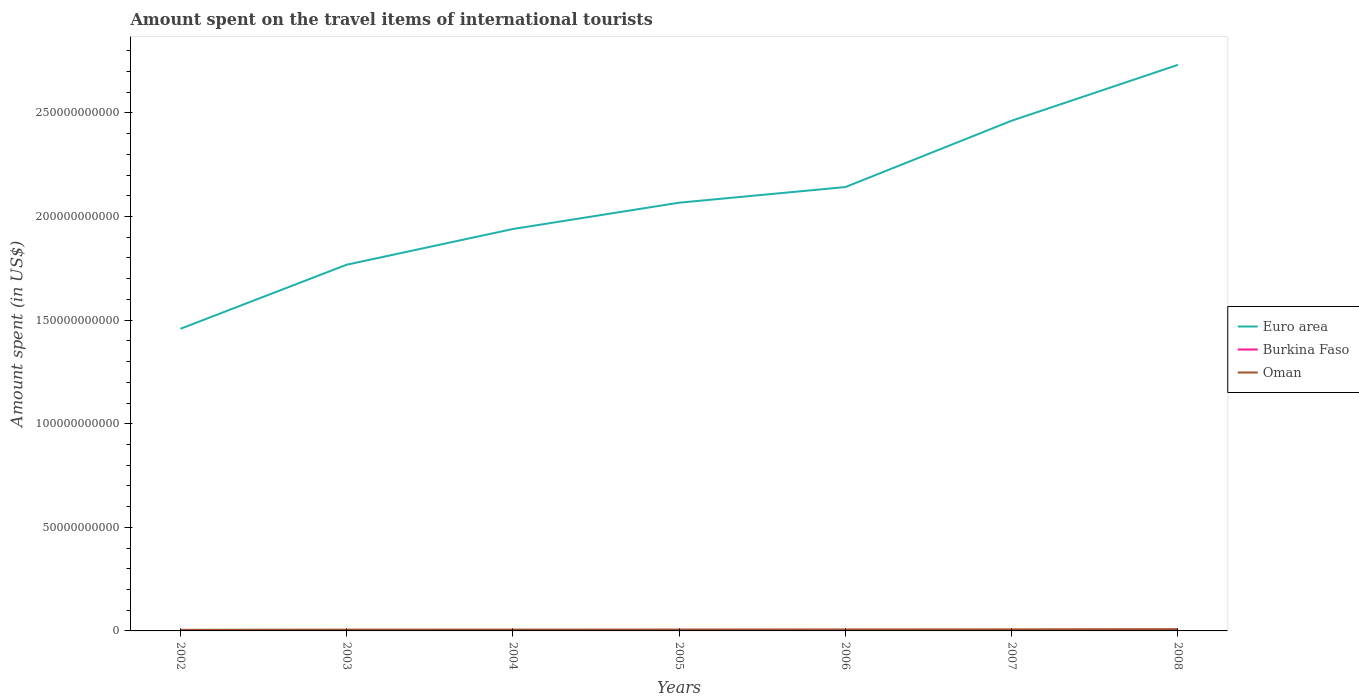How many different coloured lines are there?
Give a very brief answer. 3. Does the line corresponding to Burkina Faso intersect with the line corresponding to Oman?
Provide a succinct answer. No. Is the number of lines equal to the number of legend labels?
Give a very brief answer. Yes. Across all years, what is the maximum amount spent on the travel items of international tourists in Burkina Faso?
Give a very brief answer. 2.20e+07. In which year was the amount spent on the travel items of international tourists in Oman maximum?
Provide a succinct answer. 2002. What is the total amount spent on the travel items of international tourists in Euro area in the graph?
Your response must be concise. -1.00e+11. What is the difference between the highest and the second highest amount spent on the travel items of international tourists in Euro area?
Give a very brief answer. 1.27e+11. What is the difference between two consecutive major ticks on the Y-axis?
Your response must be concise. 5.00e+1. Are the values on the major ticks of Y-axis written in scientific E-notation?
Ensure brevity in your answer.  No. Does the graph contain any zero values?
Your answer should be compact. No. How many legend labels are there?
Ensure brevity in your answer.  3. What is the title of the graph?
Keep it short and to the point. Amount spent on the travel items of international tourists. Does "Aruba" appear as one of the legend labels in the graph?
Offer a very short reply. No. What is the label or title of the Y-axis?
Offer a terse response. Amount spent (in US$). What is the Amount spent (in US$) of Euro area in 2002?
Provide a short and direct response. 1.46e+11. What is the Amount spent (in US$) in Burkina Faso in 2002?
Your response must be concise. 2.20e+07. What is the Amount spent (in US$) of Oman in 2002?
Provide a succinct answer. 5.30e+08. What is the Amount spent (in US$) in Euro area in 2003?
Offer a very short reply. 1.77e+11. What is the Amount spent (in US$) of Burkina Faso in 2003?
Make the answer very short. 3.10e+07. What is the Amount spent (in US$) in Oman in 2003?
Provide a succinct answer. 6.30e+08. What is the Amount spent (in US$) of Euro area in 2004?
Provide a succinct answer. 1.94e+11. What is the Amount spent (in US$) of Burkina Faso in 2004?
Your response must be concise. 3.90e+07. What is the Amount spent (in US$) in Oman in 2004?
Offer a terse response. 6.44e+08. What is the Amount spent (in US$) of Euro area in 2005?
Keep it short and to the point. 2.07e+11. What is the Amount spent (in US$) in Burkina Faso in 2005?
Provide a short and direct response. 4.60e+07. What is the Amount spent (in US$) of Oman in 2005?
Your response must be concise. 6.68e+08. What is the Amount spent (in US$) of Euro area in 2006?
Provide a succinct answer. 2.14e+11. What is the Amount spent (in US$) in Burkina Faso in 2006?
Your answer should be very brief. 5.50e+07. What is the Amount spent (in US$) in Oman in 2006?
Give a very brief answer. 7.12e+08. What is the Amount spent (in US$) of Euro area in 2007?
Provide a succinct answer. 2.46e+11. What is the Amount spent (in US$) in Burkina Faso in 2007?
Your answer should be very brief. 5.80e+07. What is the Amount spent (in US$) in Oman in 2007?
Your answer should be compact. 7.52e+08. What is the Amount spent (in US$) in Euro area in 2008?
Ensure brevity in your answer.  2.73e+11. What is the Amount spent (in US$) of Burkina Faso in 2008?
Provide a succinct answer. 6.30e+07. What is the Amount spent (in US$) in Oman in 2008?
Your answer should be compact. 8.56e+08. Across all years, what is the maximum Amount spent (in US$) in Euro area?
Offer a very short reply. 2.73e+11. Across all years, what is the maximum Amount spent (in US$) of Burkina Faso?
Provide a short and direct response. 6.30e+07. Across all years, what is the maximum Amount spent (in US$) in Oman?
Offer a terse response. 8.56e+08. Across all years, what is the minimum Amount spent (in US$) in Euro area?
Make the answer very short. 1.46e+11. Across all years, what is the minimum Amount spent (in US$) in Burkina Faso?
Give a very brief answer. 2.20e+07. Across all years, what is the minimum Amount spent (in US$) of Oman?
Ensure brevity in your answer.  5.30e+08. What is the total Amount spent (in US$) of Euro area in the graph?
Provide a short and direct response. 1.46e+12. What is the total Amount spent (in US$) in Burkina Faso in the graph?
Your answer should be compact. 3.14e+08. What is the total Amount spent (in US$) in Oman in the graph?
Your answer should be very brief. 4.79e+09. What is the difference between the Amount spent (in US$) of Euro area in 2002 and that in 2003?
Provide a short and direct response. -3.09e+1. What is the difference between the Amount spent (in US$) of Burkina Faso in 2002 and that in 2003?
Offer a terse response. -9.00e+06. What is the difference between the Amount spent (in US$) in Oman in 2002 and that in 2003?
Make the answer very short. -1.00e+08. What is the difference between the Amount spent (in US$) in Euro area in 2002 and that in 2004?
Keep it short and to the point. -4.82e+1. What is the difference between the Amount spent (in US$) of Burkina Faso in 2002 and that in 2004?
Make the answer very short. -1.70e+07. What is the difference between the Amount spent (in US$) in Oman in 2002 and that in 2004?
Offer a very short reply. -1.14e+08. What is the difference between the Amount spent (in US$) of Euro area in 2002 and that in 2005?
Give a very brief answer. -6.09e+1. What is the difference between the Amount spent (in US$) in Burkina Faso in 2002 and that in 2005?
Your answer should be compact. -2.40e+07. What is the difference between the Amount spent (in US$) of Oman in 2002 and that in 2005?
Provide a short and direct response. -1.38e+08. What is the difference between the Amount spent (in US$) in Euro area in 2002 and that in 2006?
Make the answer very short. -6.84e+1. What is the difference between the Amount spent (in US$) in Burkina Faso in 2002 and that in 2006?
Your answer should be very brief. -3.30e+07. What is the difference between the Amount spent (in US$) in Oman in 2002 and that in 2006?
Your answer should be very brief. -1.82e+08. What is the difference between the Amount spent (in US$) of Euro area in 2002 and that in 2007?
Your response must be concise. -1.00e+11. What is the difference between the Amount spent (in US$) in Burkina Faso in 2002 and that in 2007?
Ensure brevity in your answer.  -3.60e+07. What is the difference between the Amount spent (in US$) in Oman in 2002 and that in 2007?
Your response must be concise. -2.22e+08. What is the difference between the Amount spent (in US$) in Euro area in 2002 and that in 2008?
Your response must be concise. -1.27e+11. What is the difference between the Amount spent (in US$) in Burkina Faso in 2002 and that in 2008?
Provide a succinct answer. -4.10e+07. What is the difference between the Amount spent (in US$) in Oman in 2002 and that in 2008?
Offer a very short reply. -3.26e+08. What is the difference between the Amount spent (in US$) of Euro area in 2003 and that in 2004?
Provide a short and direct response. -1.72e+1. What is the difference between the Amount spent (in US$) of Burkina Faso in 2003 and that in 2004?
Give a very brief answer. -8.00e+06. What is the difference between the Amount spent (in US$) of Oman in 2003 and that in 2004?
Offer a very short reply. -1.40e+07. What is the difference between the Amount spent (in US$) in Euro area in 2003 and that in 2005?
Ensure brevity in your answer.  -2.99e+1. What is the difference between the Amount spent (in US$) of Burkina Faso in 2003 and that in 2005?
Provide a short and direct response. -1.50e+07. What is the difference between the Amount spent (in US$) of Oman in 2003 and that in 2005?
Offer a very short reply. -3.80e+07. What is the difference between the Amount spent (in US$) in Euro area in 2003 and that in 2006?
Ensure brevity in your answer.  -3.75e+1. What is the difference between the Amount spent (in US$) in Burkina Faso in 2003 and that in 2006?
Offer a terse response. -2.40e+07. What is the difference between the Amount spent (in US$) in Oman in 2003 and that in 2006?
Keep it short and to the point. -8.20e+07. What is the difference between the Amount spent (in US$) of Euro area in 2003 and that in 2007?
Offer a very short reply. -6.95e+1. What is the difference between the Amount spent (in US$) of Burkina Faso in 2003 and that in 2007?
Offer a very short reply. -2.70e+07. What is the difference between the Amount spent (in US$) of Oman in 2003 and that in 2007?
Offer a terse response. -1.22e+08. What is the difference between the Amount spent (in US$) of Euro area in 2003 and that in 2008?
Provide a succinct answer. -9.65e+1. What is the difference between the Amount spent (in US$) of Burkina Faso in 2003 and that in 2008?
Your answer should be compact. -3.20e+07. What is the difference between the Amount spent (in US$) in Oman in 2003 and that in 2008?
Ensure brevity in your answer.  -2.26e+08. What is the difference between the Amount spent (in US$) in Euro area in 2004 and that in 2005?
Your response must be concise. -1.27e+1. What is the difference between the Amount spent (in US$) of Burkina Faso in 2004 and that in 2005?
Keep it short and to the point. -7.00e+06. What is the difference between the Amount spent (in US$) of Oman in 2004 and that in 2005?
Your answer should be compact. -2.40e+07. What is the difference between the Amount spent (in US$) of Euro area in 2004 and that in 2006?
Provide a succinct answer. -2.02e+1. What is the difference between the Amount spent (in US$) in Burkina Faso in 2004 and that in 2006?
Your response must be concise. -1.60e+07. What is the difference between the Amount spent (in US$) of Oman in 2004 and that in 2006?
Keep it short and to the point. -6.80e+07. What is the difference between the Amount spent (in US$) in Euro area in 2004 and that in 2007?
Your answer should be very brief. -5.23e+1. What is the difference between the Amount spent (in US$) in Burkina Faso in 2004 and that in 2007?
Keep it short and to the point. -1.90e+07. What is the difference between the Amount spent (in US$) of Oman in 2004 and that in 2007?
Your answer should be very brief. -1.08e+08. What is the difference between the Amount spent (in US$) in Euro area in 2004 and that in 2008?
Your response must be concise. -7.92e+1. What is the difference between the Amount spent (in US$) of Burkina Faso in 2004 and that in 2008?
Provide a succinct answer. -2.40e+07. What is the difference between the Amount spent (in US$) in Oman in 2004 and that in 2008?
Offer a terse response. -2.12e+08. What is the difference between the Amount spent (in US$) of Euro area in 2005 and that in 2006?
Offer a terse response. -7.54e+09. What is the difference between the Amount spent (in US$) of Burkina Faso in 2005 and that in 2006?
Provide a succinct answer. -9.00e+06. What is the difference between the Amount spent (in US$) in Oman in 2005 and that in 2006?
Provide a succinct answer. -4.40e+07. What is the difference between the Amount spent (in US$) in Euro area in 2005 and that in 2007?
Make the answer very short. -3.96e+1. What is the difference between the Amount spent (in US$) in Burkina Faso in 2005 and that in 2007?
Keep it short and to the point. -1.20e+07. What is the difference between the Amount spent (in US$) of Oman in 2005 and that in 2007?
Provide a short and direct response. -8.40e+07. What is the difference between the Amount spent (in US$) in Euro area in 2005 and that in 2008?
Ensure brevity in your answer.  -6.65e+1. What is the difference between the Amount spent (in US$) of Burkina Faso in 2005 and that in 2008?
Ensure brevity in your answer.  -1.70e+07. What is the difference between the Amount spent (in US$) in Oman in 2005 and that in 2008?
Give a very brief answer. -1.88e+08. What is the difference between the Amount spent (in US$) of Euro area in 2006 and that in 2007?
Your answer should be compact. -3.20e+1. What is the difference between the Amount spent (in US$) in Oman in 2006 and that in 2007?
Offer a very short reply. -4.00e+07. What is the difference between the Amount spent (in US$) of Euro area in 2006 and that in 2008?
Give a very brief answer. -5.90e+1. What is the difference between the Amount spent (in US$) in Burkina Faso in 2006 and that in 2008?
Make the answer very short. -8.00e+06. What is the difference between the Amount spent (in US$) in Oman in 2006 and that in 2008?
Provide a short and direct response. -1.44e+08. What is the difference between the Amount spent (in US$) of Euro area in 2007 and that in 2008?
Offer a terse response. -2.70e+1. What is the difference between the Amount spent (in US$) of Burkina Faso in 2007 and that in 2008?
Provide a short and direct response. -5.00e+06. What is the difference between the Amount spent (in US$) in Oman in 2007 and that in 2008?
Ensure brevity in your answer.  -1.04e+08. What is the difference between the Amount spent (in US$) of Euro area in 2002 and the Amount spent (in US$) of Burkina Faso in 2003?
Make the answer very short. 1.46e+11. What is the difference between the Amount spent (in US$) in Euro area in 2002 and the Amount spent (in US$) in Oman in 2003?
Your answer should be compact. 1.45e+11. What is the difference between the Amount spent (in US$) of Burkina Faso in 2002 and the Amount spent (in US$) of Oman in 2003?
Offer a very short reply. -6.08e+08. What is the difference between the Amount spent (in US$) in Euro area in 2002 and the Amount spent (in US$) in Burkina Faso in 2004?
Offer a very short reply. 1.46e+11. What is the difference between the Amount spent (in US$) in Euro area in 2002 and the Amount spent (in US$) in Oman in 2004?
Your answer should be compact. 1.45e+11. What is the difference between the Amount spent (in US$) of Burkina Faso in 2002 and the Amount spent (in US$) of Oman in 2004?
Ensure brevity in your answer.  -6.22e+08. What is the difference between the Amount spent (in US$) of Euro area in 2002 and the Amount spent (in US$) of Burkina Faso in 2005?
Offer a terse response. 1.46e+11. What is the difference between the Amount spent (in US$) of Euro area in 2002 and the Amount spent (in US$) of Oman in 2005?
Offer a terse response. 1.45e+11. What is the difference between the Amount spent (in US$) of Burkina Faso in 2002 and the Amount spent (in US$) of Oman in 2005?
Give a very brief answer. -6.46e+08. What is the difference between the Amount spent (in US$) of Euro area in 2002 and the Amount spent (in US$) of Burkina Faso in 2006?
Provide a succinct answer. 1.46e+11. What is the difference between the Amount spent (in US$) in Euro area in 2002 and the Amount spent (in US$) in Oman in 2006?
Give a very brief answer. 1.45e+11. What is the difference between the Amount spent (in US$) in Burkina Faso in 2002 and the Amount spent (in US$) in Oman in 2006?
Keep it short and to the point. -6.90e+08. What is the difference between the Amount spent (in US$) of Euro area in 2002 and the Amount spent (in US$) of Burkina Faso in 2007?
Provide a short and direct response. 1.46e+11. What is the difference between the Amount spent (in US$) in Euro area in 2002 and the Amount spent (in US$) in Oman in 2007?
Keep it short and to the point. 1.45e+11. What is the difference between the Amount spent (in US$) of Burkina Faso in 2002 and the Amount spent (in US$) of Oman in 2007?
Your answer should be very brief. -7.30e+08. What is the difference between the Amount spent (in US$) of Euro area in 2002 and the Amount spent (in US$) of Burkina Faso in 2008?
Provide a succinct answer. 1.46e+11. What is the difference between the Amount spent (in US$) of Euro area in 2002 and the Amount spent (in US$) of Oman in 2008?
Your answer should be very brief. 1.45e+11. What is the difference between the Amount spent (in US$) of Burkina Faso in 2002 and the Amount spent (in US$) of Oman in 2008?
Ensure brevity in your answer.  -8.34e+08. What is the difference between the Amount spent (in US$) in Euro area in 2003 and the Amount spent (in US$) in Burkina Faso in 2004?
Your answer should be compact. 1.77e+11. What is the difference between the Amount spent (in US$) of Euro area in 2003 and the Amount spent (in US$) of Oman in 2004?
Offer a terse response. 1.76e+11. What is the difference between the Amount spent (in US$) of Burkina Faso in 2003 and the Amount spent (in US$) of Oman in 2004?
Offer a terse response. -6.13e+08. What is the difference between the Amount spent (in US$) of Euro area in 2003 and the Amount spent (in US$) of Burkina Faso in 2005?
Your response must be concise. 1.77e+11. What is the difference between the Amount spent (in US$) of Euro area in 2003 and the Amount spent (in US$) of Oman in 2005?
Give a very brief answer. 1.76e+11. What is the difference between the Amount spent (in US$) of Burkina Faso in 2003 and the Amount spent (in US$) of Oman in 2005?
Keep it short and to the point. -6.37e+08. What is the difference between the Amount spent (in US$) of Euro area in 2003 and the Amount spent (in US$) of Burkina Faso in 2006?
Your answer should be very brief. 1.77e+11. What is the difference between the Amount spent (in US$) of Euro area in 2003 and the Amount spent (in US$) of Oman in 2006?
Provide a short and direct response. 1.76e+11. What is the difference between the Amount spent (in US$) of Burkina Faso in 2003 and the Amount spent (in US$) of Oman in 2006?
Your response must be concise. -6.81e+08. What is the difference between the Amount spent (in US$) of Euro area in 2003 and the Amount spent (in US$) of Burkina Faso in 2007?
Provide a succinct answer. 1.77e+11. What is the difference between the Amount spent (in US$) of Euro area in 2003 and the Amount spent (in US$) of Oman in 2007?
Give a very brief answer. 1.76e+11. What is the difference between the Amount spent (in US$) of Burkina Faso in 2003 and the Amount spent (in US$) of Oman in 2007?
Ensure brevity in your answer.  -7.21e+08. What is the difference between the Amount spent (in US$) of Euro area in 2003 and the Amount spent (in US$) of Burkina Faso in 2008?
Your answer should be compact. 1.77e+11. What is the difference between the Amount spent (in US$) of Euro area in 2003 and the Amount spent (in US$) of Oman in 2008?
Provide a succinct answer. 1.76e+11. What is the difference between the Amount spent (in US$) in Burkina Faso in 2003 and the Amount spent (in US$) in Oman in 2008?
Provide a succinct answer. -8.25e+08. What is the difference between the Amount spent (in US$) of Euro area in 2004 and the Amount spent (in US$) of Burkina Faso in 2005?
Your answer should be compact. 1.94e+11. What is the difference between the Amount spent (in US$) in Euro area in 2004 and the Amount spent (in US$) in Oman in 2005?
Make the answer very short. 1.93e+11. What is the difference between the Amount spent (in US$) in Burkina Faso in 2004 and the Amount spent (in US$) in Oman in 2005?
Offer a very short reply. -6.29e+08. What is the difference between the Amount spent (in US$) of Euro area in 2004 and the Amount spent (in US$) of Burkina Faso in 2006?
Provide a succinct answer. 1.94e+11. What is the difference between the Amount spent (in US$) of Euro area in 2004 and the Amount spent (in US$) of Oman in 2006?
Your answer should be compact. 1.93e+11. What is the difference between the Amount spent (in US$) of Burkina Faso in 2004 and the Amount spent (in US$) of Oman in 2006?
Provide a short and direct response. -6.73e+08. What is the difference between the Amount spent (in US$) of Euro area in 2004 and the Amount spent (in US$) of Burkina Faso in 2007?
Your answer should be very brief. 1.94e+11. What is the difference between the Amount spent (in US$) in Euro area in 2004 and the Amount spent (in US$) in Oman in 2007?
Provide a short and direct response. 1.93e+11. What is the difference between the Amount spent (in US$) of Burkina Faso in 2004 and the Amount spent (in US$) of Oman in 2007?
Your answer should be very brief. -7.13e+08. What is the difference between the Amount spent (in US$) in Euro area in 2004 and the Amount spent (in US$) in Burkina Faso in 2008?
Your response must be concise. 1.94e+11. What is the difference between the Amount spent (in US$) in Euro area in 2004 and the Amount spent (in US$) in Oman in 2008?
Ensure brevity in your answer.  1.93e+11. What is the difference between the Amount spent (in US$) in Burkina Faso in 2004 and the Amount spent (in US$) in Oman in 2008?
Make the answer very short. -8.17e+08. What is the difference between the Amount spent (in US$) in Euro area in 2005 and the Amount spent (in US$) in Burkina Faso in 2006?
Give a very brief answer. 2.07e+11. What is the difference between the Amount spent (in US$) in Euro area in 2005 and the Amount spent (in US$) in Oman in 2006?
Give a very brief answer. 2.06e+11. What is the difference between the Amount spent (in US$) of Burkina Faso in 2005 and the Amount spent (in US$) of Oman in 2006?
Ensure brevity in your answer.  -6.66e+08. What is the difference between the Amount spent (in US$) of Euro area in 2005 and the Amount spent (in US$) of Burkina Faso in 2007?
Offer a terse response. 2.07e+11. What is the difference between the Amount spent (in US$) in Euro area in 2005 and the Amount spent (in US$) in Oman in 2007?
Keep it short and to the point. 2.06e+11. What is the difference between the Amount spent (in US$) of Burkina Faso in 2005 and the Amount spent (in US$) of Oman in 2007?
Make the answer very short. -7.06e+08. What is the difference between the Amount spent (in US$) in Euro area in 2005 and the Amount spent (in US$) in Burkina Faso in 2008?
Provide a short and direct response. 2.07e+11. What is the difference between the Amount spent (in US$) of Euro area in 2005 and the Amount spent (in US$) of Oman in 2008?
Your response must be concise. 2.06e+11. What is the difference between the Amount spent (in US$) in Burkina Faso in 2005 and the Amount spent (in US$) in Oman in 2008?
Make the answer very short. -8.10e+08. What is the difference between the Amount spent (in US$) in Euro area in 2006 and the Amount spent (in US$) in Burkina Faso in 2007?
Your answer should be compact. 2.14e+11. What is the difference between the Amount spent (in US$) in Euro area in 2006 and the Amount spent (in US$) in Oman in 2007?
Your answer should be compact. 2.13e+11. What is the difference between the Amount spent (in US$) in Burkina Faso in 2006 and the Amount spent (in US$) in Oman in 2007?
Your answer should be compact. -6.97e+08. What is the difference between the Amount spent (in US$) in Euro area in 2006 and the Amount spent (in US$) in Burkina Faso in 2008?
Your answer should be compact. 2.14e+11. What is the difference between the Amount spent (in US$) of Euro area in 2006 and the Amount spent (in US$) of Oman in 2008?
Ensure brevity in your answer.  2.13e+11. What is the difference between the Amount spent (in US$) of Burkina Faso in 2006 and the Amount spent (in US$) of Oman in 2008?
Ensure brevity in your answer.  -8.01e+08. What is the difference between the Amount spent (in US$) of Euro area in 2007 and the Amount spent (in US$) of Burkina Faso in 2008?
Provide a succinct answer. 2.46e+11. What is the difference between the Amount spent (in US$) of Euro area in 2007 and the Amount spent (in US$) of Oman in 2008?
Provide a short and direct response. 2.45e+11. What is the difference between the Amount spent (in US$) in Burkina Faso in 2007 and the Amount spent (in US$) in Oman in 2008?
Provide a succinct answer. -7.98e+08. What is the average Amount spent (in US$) of Euro area per year?
Make the answer very short. 2.08e+11. What is the average Amount spent (in US$) in Burkina Faso per year?
Your response must be concise. 4.49e+07. What is the average Amount spent (in US$) of Oman per year?
Your answer should be very brief. 6.85e+08. In the year 2002, what is the difference between the Amount spent (in US$) of Euro area and Amount spent (in US$) of Burkina Faso?
Keep it short and to the point. 1.46e+11. In the year 2002, what is the difference between the Amount spent (in US$) in Euro area and Amount spent (in US$) in Oman?
Give a very brief answer. 1.45e+11. In the year 2002, what is the difference between the Amount spent (in US$) of Burkina Faso and Amount spent (in US$) of Oman?
Your answer should be very brief. -5.08e+08. In the year 2003, what is the difference between the Amount spent (in US$) in Euro area and Amount spent (in US$) in Burkina Faso?
Provide a short and direct response. 1.77e+11. In the year 2003, what is the difference between the Amount spent (in US$) of Euro area and Amount spent (in US$) of Oman?
Offer a terse response. 1.76e+11. In the year 2003, what is the difference between the Amount spent (in US$) in Burkina Faso and Amount spent (in US$) in Oman?
Your answer should be compact. -5.99e+08. In the year 2004, what is the difference between the Amount spent (in US$) of Euro area and Amount spent (in US$) of Burkina Faso?
Your response must be concise. 1.94e+11. In the year 2004, what is the difference between the Amount spent (in US$) in Euro area and Amount spent (in US$) in Oman?
Your response must be concise. 1.93e+11. In the year 2004, what is the difference between the Amount spent (in US$) in Burkina Faso and Amount spent (in US$) in Oman?
Your answer should be very brief. -6.05e+08. In the year 2005, what is the difference between the Amount spent (in US$) in Euro area and Amount spent (in US$) in Burkina Faso?
Make the answer very short. 2.07e+11. In the year 2005, what is the difference between the Amount spent (in US$) in Euro area and Amount spent (in US$) in Oman?
Your response must be concise. 2.06e+11. In the year 2005, what is the difference between the Amount spent (in US$) in Burkina Faso and Amount spent (in US$) in Oman?
Offer a terse response. -6.22e+08. In the year 2006, what is the difference between the Amount spent (in US$) in Euro area and Amount spent (in US$) in Burkina Faso?
Provide a succinct answer. 2.14e+11. In the year 2006, what is the difference between the Amount spent (in US$) of Euro area and Amount spent (in US$) of Oman?
Give a very brief answer. 2.14e+11. In the year 2006, what is the difference between the Amount spent (in US$) of Burkina Faso and Amount spent (in US$) of Oman?
Provide a short and direct response. -6.57e+08. In the year 2007, what is the difference between the Amount spent (in US$) of Euro area and Amount spent (in US$) of Burkina Faso?
Your answer should be very brief. 2.46e+11. In the year 2007, what is the difference between the Amount spent (in US$) of Euro area and Amount spent (in US$) of Oman?
Your answer should be very brief. 2.46e+11. In the year 2007, what is the difference between the Amount spent (in US$) in Burkina Faso and Amount spent (in US$) in Oman?
Your answer should be compact. -6.94e+08. In the year 2008, what is the difference between the Amount spent (in US$) in Euro area and Amount spent (in US$) in Burkina Faso?
Ensure brevity in your answer.  2.73e+11. In the year 2008, what is the difference between the Amount spent (in US$) of Euro area and Amount spent (in US$) of Oman?
Keep it short and to the point. 2.72e+11. In the year 2008, what is the difference between the Amount spent (in US$) in Burkina Faso and Amount spent (in US$) in Oman?
Your response must be concise. -7.93e+08. What is the ratio of the Amount spent (in US$) in Euro area in 2002 to that in 2003?
Offer a very short reply. 0.82. What is the ratio of the Amount spent (in US$) in Burkina Faso in 2002 to that in 2003?
Offer a terse response. 0.71. What is the ratio of the Amount spent (in US$) of Oman in 2002 to that in 2003?
Give a very brief answer. 0.84. What is the ratio of the Amount spent (in US$) in Euro area in 2002 to that in 2004?
Your answer should be compact. 0.75. What is the ratio of the Amount spent (in US$) of Burkina Faso in 2002 to that in 2004?
Provide a short and direct response. 0.56. What is the ratio of the Amount spent (in US$) of Oman in 2002 to that in 2004?
Your answer should be compact. 0.82. What is the ratio of the Amount spent (in US$) in Euro area in 2002 to that in 2005?
Provide a short and direct response. 0.71. What is the ratio of the Amount spent (in US$) in Burkina Faso in 2002 to that in 2005?
Provide a short and direct response. 0.48. What is the ratio of the Amount spent (in US$) of Oman in 2002 to that in 2005?
Your response must be concise. 0.79. What is the ratio of the Amount spent (in US$) of Euro area in 2002 to that in 2006?
Give a very brief answer. 0.68. What is the ratio of the Amount spent (in US$) in Oman in 2002 to that in 2006?
Your response must be concise. 0.74. What is the ratio of the Amount spent (in US$) in Euro area in 2002 to that in 2007?
Ensure brevity in your answer.  0.59. What is the ratio of the Amount spent (in US$) of Burkina Faso in 2002 to that in 2007?
Offer a terse response. 0.38. What is the ratio of the Amount spent (in US$) of Oman in 2002 to that in 2007?
Offer a very short reply. 0.7. What is the ratio of the Amount spent (in US$) of Euro area in 2002 to that in 2008?
Give a very brief answer. 0.53. What is the ratio of the Amount spent (in US$) in Burkina Faso in 2002 to that in 2008?
Provide a succinct answer. 0.35. What is the ratio of the Amount spent (in US$) in Oman in 2002 to that in 2008?
Keep it short and to the point. 0.62. What is the ratio of the Amount spent (in US$) of Euro area in 2003 to that in 2004?
Offer a very short reply. 0.91. What is the ratio of the Amount spent (in US$) of Burkina Faso in 2003 to that in 2004?
Offer a very short reply. 0.79. What is the ratio of the Amount spent (in US$) of Oman in 2003 to that in 2004?
Offer a very short reply. 0.98. What is the ratio of the Amount spent (in US$) of Euro area in 2003 to that in 2005?
Give a very brief answer. 0.86. What is the ratio of the Amount spent (in US$) of Burkina Faso in 2003 to that in 2005?
Provide a succinct answer. 0.67. What is the ratio of the Amount spent (in US$) of Oman in 2003 to that in 2005?
Your response must be concise. 0.94. What is the ratio of the Amount spent (in US$) of Euro area in 2003 to that in 2006?
Make the answer very short. 0.83. What is the ratio of the Amount spent (in US$) in Burkina Faso in 2003 to that in 2006?
Your answer should be compact. 0.56. What is the ratio of the Amount spent (in US$) in Oman in 2003 to that in 2006?
Offer a very short reply. 0.88. What is the ratio of the Amount spent (in US$) of Euro area in 2003 to that in 2007?
Give a very brief answer. 0.72. What is the ratio of the Amount spent (in US$) of Burkina Faso in 2003 to that in 2007?
Provide a succinct answer. 0.53. What is the ratio of the Amount spent (in US$) in Oman in 2003 to that in 2007?
Keep it short and to the point. 0.84. What is the ratio of the Amount spent (in US$) in Euro area in 2003 to that in 2008?
Your answer should be compact. 0.65. What is the ratio of the Amount spent (in US$) of Burkina Faso in 2003 to that in 2008?
Your answer should be very brief. 0.49. What is the ratio of the Amount spent (in US$) in Oman in 2003 to that in 2008?
Offer a very short reply. 0.74. What is the ratio of the Amount spent (in US$) in Euro area in 2004 to that in 2005?
Make the answer very short. 0.94. What is the ratio of the Amount spent (in US$) of Burkina Faso in 2004 to that in 2005?
Offer a terse response. 0.85. What is the ratio of the Amount spent (in US$) in Oman in 2004 to that in 2005?
Your answer should be compact. 0.96. What is the ratio of the Amount spent (in US$) of Euro area in 2004 to that in 2006?
Keep it short and to the point. 0.91. What is the ratio of the Amount spent (in US$) in Burkina Faso in 2004 to that in 2006?
Provide a short and direct response. 0.71. What is the ratio of the Amount spent (in US$) of Oman in 2004 to that in 2006?
Your answer should be compact. 0.9. What is the ratio of the Amount spent (in US$) of Euro area in 2004 to that in 2007?
Ensure brevity in your answer.  0.79. What is the ratio of the Amount spent (in US$) in Burkina Faso in 2004 to that in 2007?
Give a very brief answer. 0.67. What is the ratio of the Amount spent (in US$) of Oman in 2004 to that in 2007?
Give a very brief answer. 0.86. What is the ratio of the Amount spent (in US$) of Euro area in 2004 to that in 2008?
Ensure brevity in your answer.  0.71. What is the ratio of the Amount spent (in US$) of Burkina Faso in 2004 to that in 2008?
Give a very brief answer. 0.62. What is the ratio of the Amount spent (in US$) of Oman in 2004 to that in 2008?
Make the answer very short. 0.75. What is the ratio of the Amount spent (in US$) of Euro area in 2005 to that in 2006?
Give a very brief answer. 0.96. What is the ratio of the Amount spent (in US$) in Burkina Faso in 2005 to that in 2006?
Offer a terse response. 0.84. What is the ratio of the Amount spent (in US$) of Oman in 2005 to that in 2006?
Ensure brevity in your answer.  0.94. What is the ratio of the Amount spent (in US$) in Euro area in 2005 to that in 2007?
Keep it short and to the point. 0.84. What is the ratio of the Amount spent (in US$) of Burkina Faso in 2005 to that in 2007?
Provide a succinct answer. 0.79. What is the ratio of the Amount spent (in US$) in Oman in 2005 to that in 2007?
Offer a very short reply. 0.89. What is the ratio of the Amount spent (in US$) of Euro area in 2005 to that in 2008?
Your answer should be very brief. 0.76. What is the ratio of the Amount spent (in US$) of Burkina Faso in 2005 to that in 2008?
Provide a succinct answer. 0.73. What is the ratio of the Amount spent (in US$) of Oman in 2005 to that in 2008?
Offer a terse response. 0.78. What is the ratio of the Amount spent (in US$) in Euro area in 2006 to that in 2007?
Keep it short and to the point. 0.87. What is the ratio of the Amount spent (in US$) in Burkina Faso in 2006 to that in 2007?
Provide a succinct answer. 0.95. What is the ratio of the Amount spent (in US$) in Oman in 2006 to that in 2007?
Give a very brief answer. 0.95. What is the ratio of the Amount spent (in US$) of Euro area in 2006 to that in 2008?
Offer a very short reply. 0.78. What is the ratio of the Amount spent (in US$) of Burkina Faso in 2006 to that in 2008?
Keep it short and to the point. 0.87. What is the ratio of the Amount spent (in US$) in Oman in 2006 to that in 2008?
Offer a very short reply. 0.83. What is the ratio of the Amount spent (in US$) in Euro area in 2007 to that in 2008?
Provide a succinct answer. 0.9. What is the ratio of the Amount spent (in US$) in Burkina Faso in 2007 to that in 2008?
Your response must be concise. 0.92. What is the ratio of the Amount spent (in US$) of Oman in 2007 to that in 2008?
Provide a succinct answer. 0.88. What is the difference between the highest and the second highest Amount spent (in US$) in Euro area?
Your answer should be very brief. 2.70e+1. What is the difference between the highest and the second highest Amount spent (in US$) in Burkina Faso?
Offer a very short reply. 5.00e+06. What is the difference between the highest and the second highest Amount spent (in US$) of Oman?
Give a very brief answer. 1.04e+08. What is the difference between the highest and the lowest Amount spent (in US$) in Euro area?
Your response must be concise. 1.27e+11. What is the difference between the highest and the lowest Amount spent (in US$) of Burkina Faso?
Provide a succinct answer. 4.10e+07. What is the difference between the highest and the lowest Amount spent (in US$) in Oman?
Your response must be concise. 3.26e+08. 